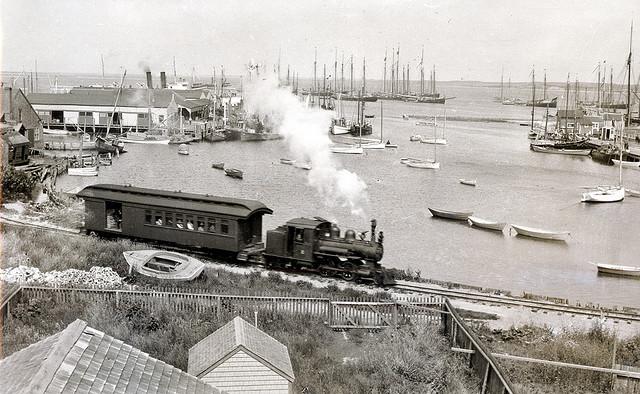Is this a train wreck?
Short answer required. No. Is this next to the water?
Concise answer only. Yes. What is train hauling?
Answer briefly. Passengers. Is this in color?
Give a very brief answer. No. How many boats can be seen?
Quick response, please. 10. Which direction is the train traveling?
Be succinct. Right. 